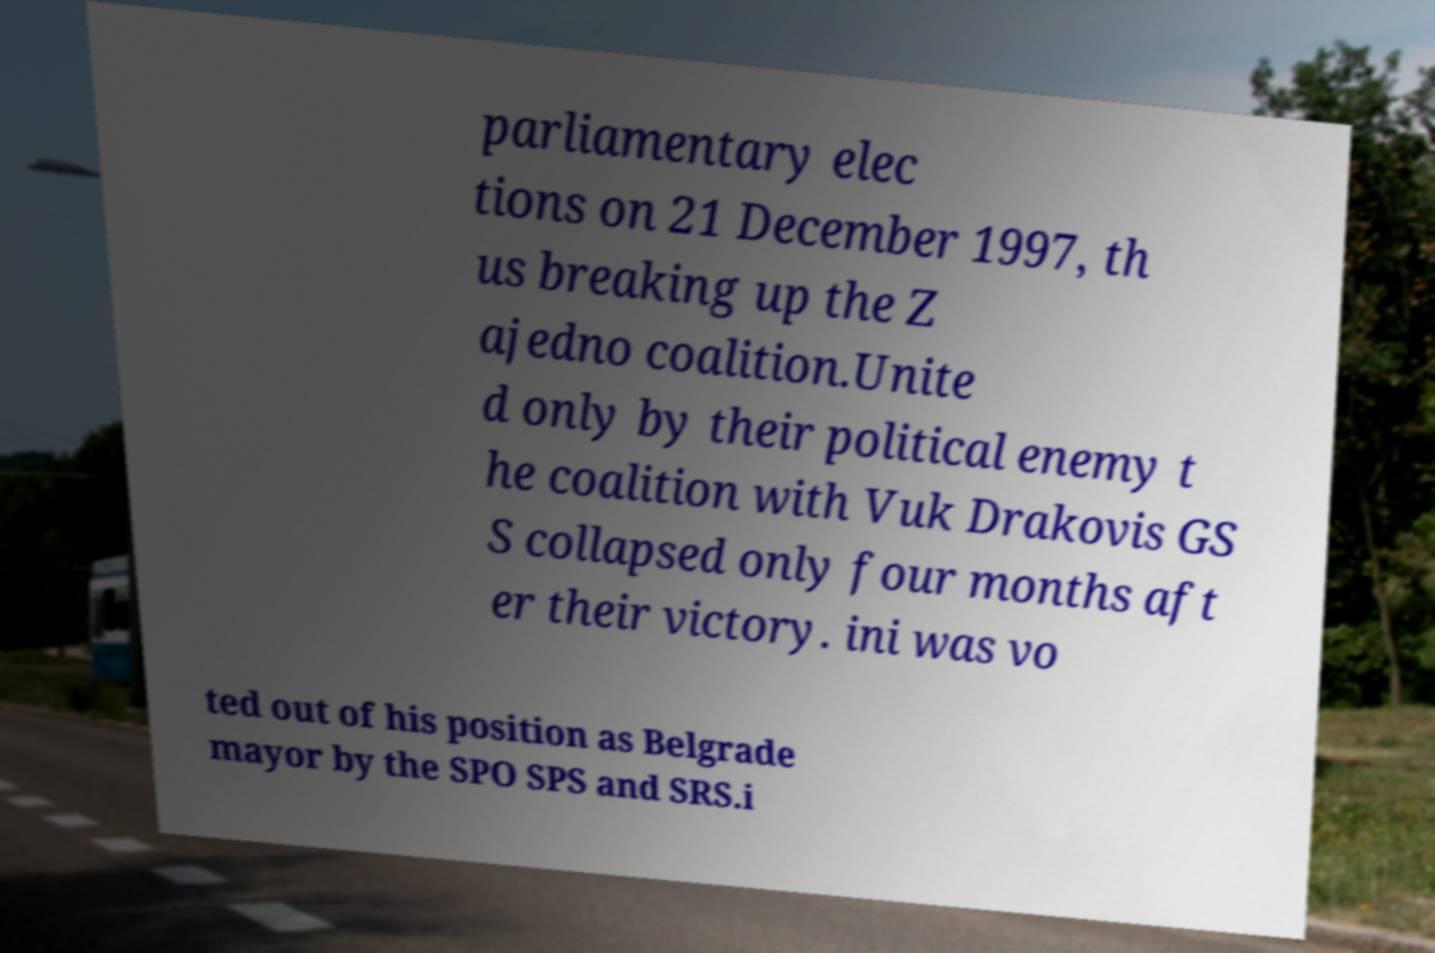Could you extract and type out the text from this image? parliamentary elec tions on 21 December 1997, th us breaking up the Z ajedno coalition.Unite d only by their political enemy t he coalition with Vuk Drakovis GS S collapsed only four months aft er their victory. ini was vo ted out of his position as Belgrade mayor by the SPO SPS and SRS.i 